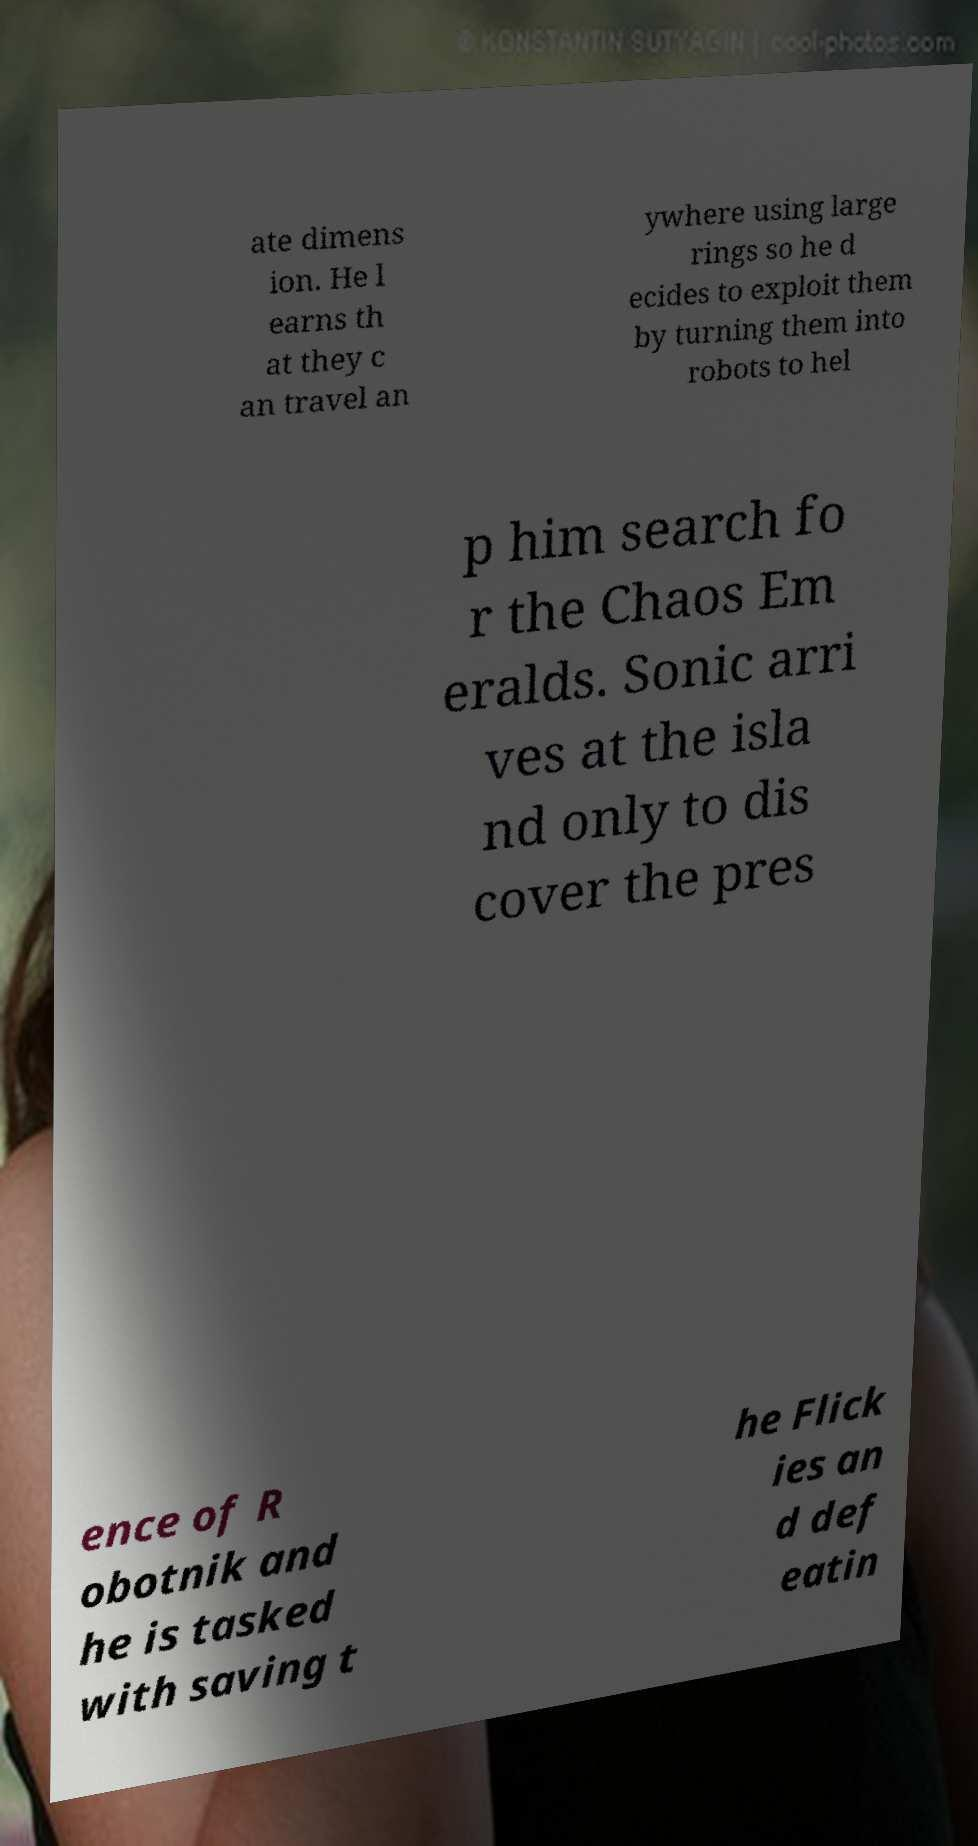Can you read and provide the text displayed in the image?This photo seems to have some interesting text. Can you extract and type it out for me? ate dimens ion. He l earns th at they c an travel an ywhere using large rings so he d ecides to exploit them by turning them into robots to hel p him search fo r the Chaos Em eralds. Sonic arri ves at the isla nd only to dis cover the pres ence of R obotnik and he is tasked with saving t he Flick ies an d def eatin 